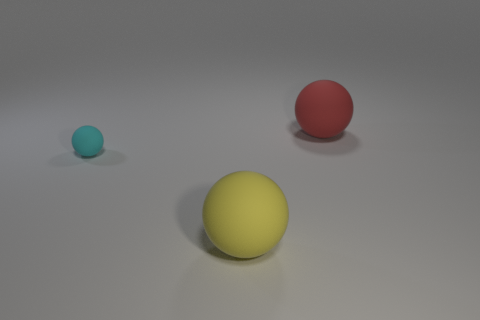Add 2 yellow matte balls. How many objects exist? 5 Subtract all cyan matte balls. How many balls are left? 2 Subtract 1 balls. How many balls are left? 2 Subtract all brown balls. Subtract all brown cylinders. How many balls are left? 3 Subtract all green cubes. How many brown balls are left? 0 Subtract all small cyan things. Subtract all big yellow rubber objects. How many objects are left? 1 Add 1 red balls. How many red balls are left? 2 Add 2 green metallic cylinders. How many green metallic cylinders exist? 2 Subtract 0 red cylinders. How many objects are left? 3 